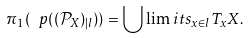<formula> <loc_0><loc_0><loc_500><loc_500>\pi _ { 1 } ( \ p ( ( \mathcal { P } _ { X } ) _ { | l } ) ) = { \bigcup \lim i t s _ { x \in l } } T _ { x } X .</formula> 